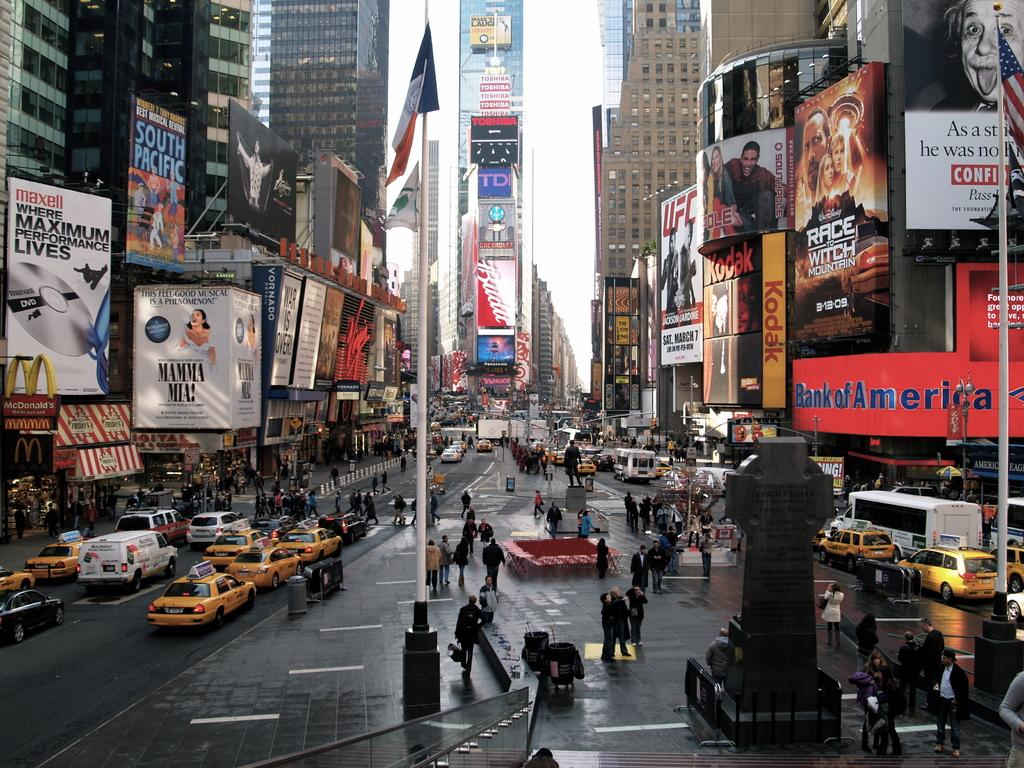Provide a one-sentence caption for the provided image. a bank of america sign that is outside of a building. 